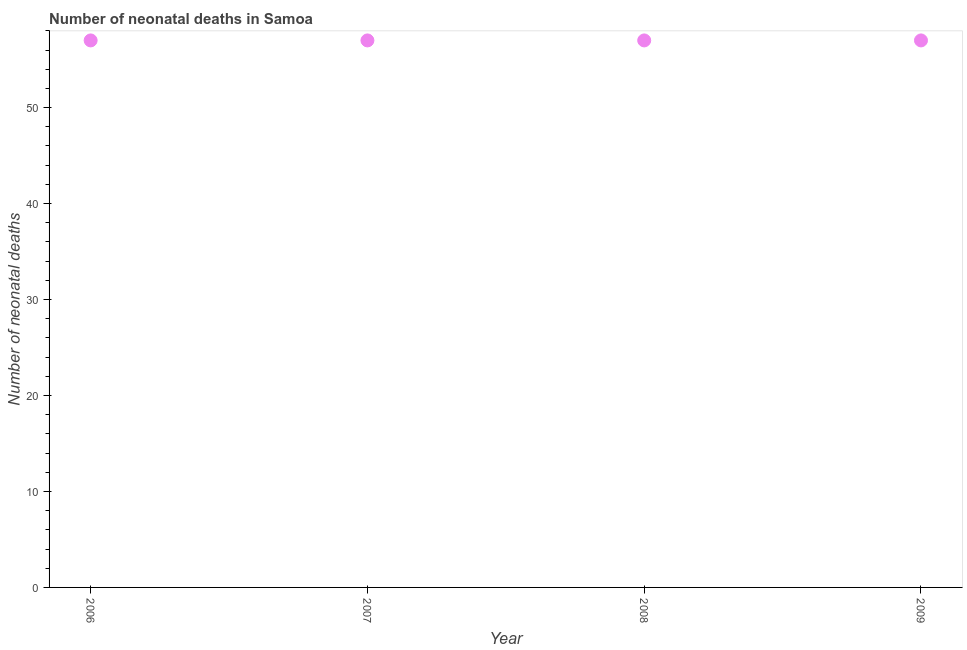What is the number of neonatal deaths in 2008?
Offer a very short reply. 57. Across all years, what is the maximum number of neonatal deaths?
Give a very brief answer. 57. Across all years, what is the minimum number of neonatal deaths?
Offer a very short reply. 57. In which year was the number of neonatal deaths maximum?
Make the answer very short. 2006. In which year was the number of neonatal deaths minimum?
Ensure brevity in your answer.  2006. What is the sum of the number of neonatal deaths?
Offer a terse response. 228. What is the average number of neonatal deaths per year?
Ensure brevity in your answer.  57. What is the median number of neonatal deaths?
Ensure brevity in your answer.  57. What is the ratio of the number of neonatal deaths in 2006 to that in 2009?
Ensure brevity in your answer.  1. Is the difference between the number of neonatal deaths in 2007 and 2009 greater than the difference between any two years?
Offer a very short reply. Yes. What is the difference between the highest and the second highest number of neonatal deaths?
Keep it short and to the point. 0. Is the sum of the number of neonatal deaths in 2006 and 2007 greater than the maximum number of neonatal deaths across all years?
Make the answer very short. Yes. In how many years, is the number of neonatal deaths greater than the average number of neonatal deaths taken over all years?
Make the answer very short. 0. How many dotlines are there?
Your answer should be compact. 1. What is the difference between two consecutive major ticks on the Y-axis?
Give a very brief answer. 10. What is the title of the graph?
Make the answer very short. Number of neonatal deaths in Samoa. What is the label or title of the Y-axis?
Ensure brevity in your answer.  Number of neonatal deaths. What is the Number of neonatal deaths in 2008?
Your answer should be very brief. 57. What is the difference between the Number of neonatal deaths in 2006 and 2009?
Make the answer very short. 0. What is the difference between the Number of neonatal deaths in 2007 and 2008?
Give a very brief answer. 0. What is the difference between the Number of neonatal deaths in 2007 and 2009?
Provide a succinct answer. 0. What is the ratio of the Number of neonatal deaths in 2006 to that in 2007?
Give a very brief answer. 1. What is the ratio of the Number of neonatal deaths in 2006 to that in 2009?
Offer a very short reply. 1. What is the ratio of the Number of neonatal deaths in 2007 to that in 2009?
Provide a succinct answer. 1. What is the ratio of the Number of neonatal deaths in 2008 to that in 2009?
Your answer should be very brief. 1. 